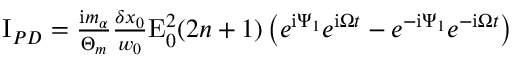<formula> <loc_0><loc_0><loc_500><loc_500>\begin{array} { r } { I _ { P D } = \frac { i m _ { \alpha } } { \Theta _ { m } } \frac { \delta x _ { 0 } } { w _ { 0 } } E _ { 0 } ^ { 2 } ( 2 n + 1 ) \left ( e ^ { i \Psi _ { 1 } } e ^ { i \Omega t } - e ^ { - i \Psi _ { 1 } } e ^ { - i \Omega t } \right ) } \end{array}</formula> 